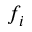Convert formula to latex. <formula><loc_0><loc_0><loc_500><loc_500>f _ { i }</formula> 